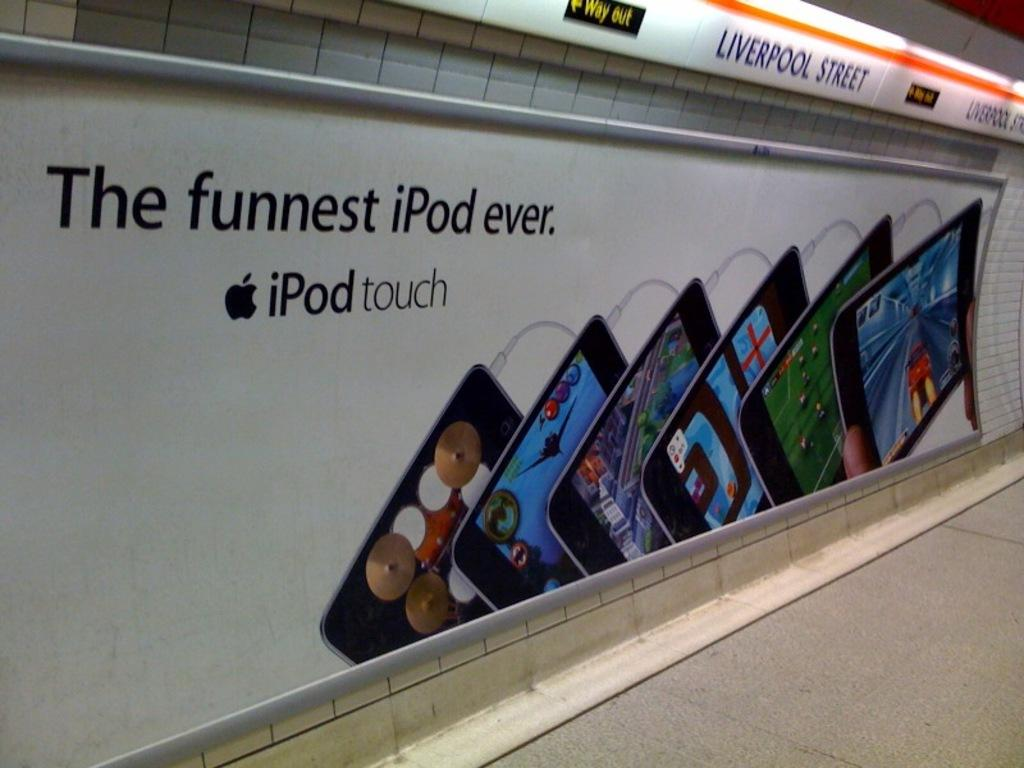<image>
Share a concise interpretation of the image provided. A advertising board for the iPod touch in Liverpool street. 